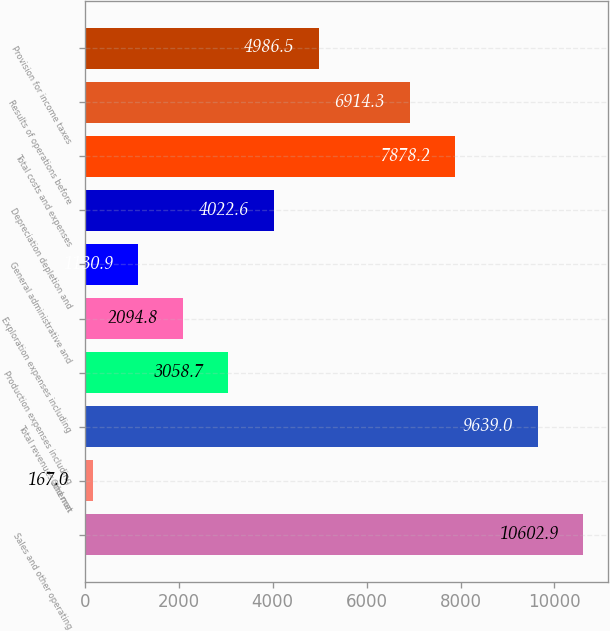Convert chart to OTSL. <chart><loc_0><loc_0><loc_500><loc_500><bar_chart><fcel>Sales and other operating<fcel>Othernet<fcel>Total revenues and non<fcel>Production expenses including<fcel>Exploration expenses including<fcel>General administrative and<fcel>Depreciation depletion and<fcel>Total costs and expenses<fcel>Results of operations before<fcel>Provision for income taxes<nl><fcel>10602.9<fcel>167<fcel>9639<fcel>3058.7<fcel>2094.8<fcel>1130.9<fcel>4022.6<fcel>7878.2<fcel>6914.3<fcel>4986.5<nl></chart> 